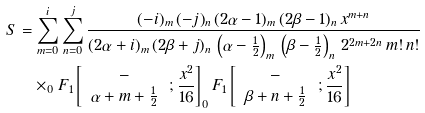<formula> <loc_0><loc_0><loc_500><loc_500>S & = \sum _ { m = 0 } ^ { i } \sum _ { n = 0 } ^ { j } \frac { ( - i ) _ { m } \, ( - j ) _ { n } \, ( 2 \alpha - 1 ) _ { m } \, ( 2 \beta - 1 ) _ { n } \, x ^ { m + n } } { ( 2 \alpha + i ) _ { m } \, ( 2 \beta + j ) _ { n } \, \left ( \alpha - \frac { 1 } { 2 } \right ) _ { m } \, \left ( \beta - \frac { 1 } { 2 } \right ) _ { n } \, 2 ^ { 2 m + 2 n } \, m ! \, n ! } \\ & \quad \times _ { 0 } F _ { 1 } \left [ \begin{array} { c } - \, \\ \alpha + m + \frac { 1 } { 2 } \, \end{array} ; \frac { x ^ { 2 } } { 1 6 } \right ] _ { 0 } F _ { 1 } \left [ \begin{array} { c } - \, \\ \beta + n + \frac { 1 } { 2 } \, \end{array} ; \frac { x ^ { 2 } } { 1 6 } \right ]</formula> 